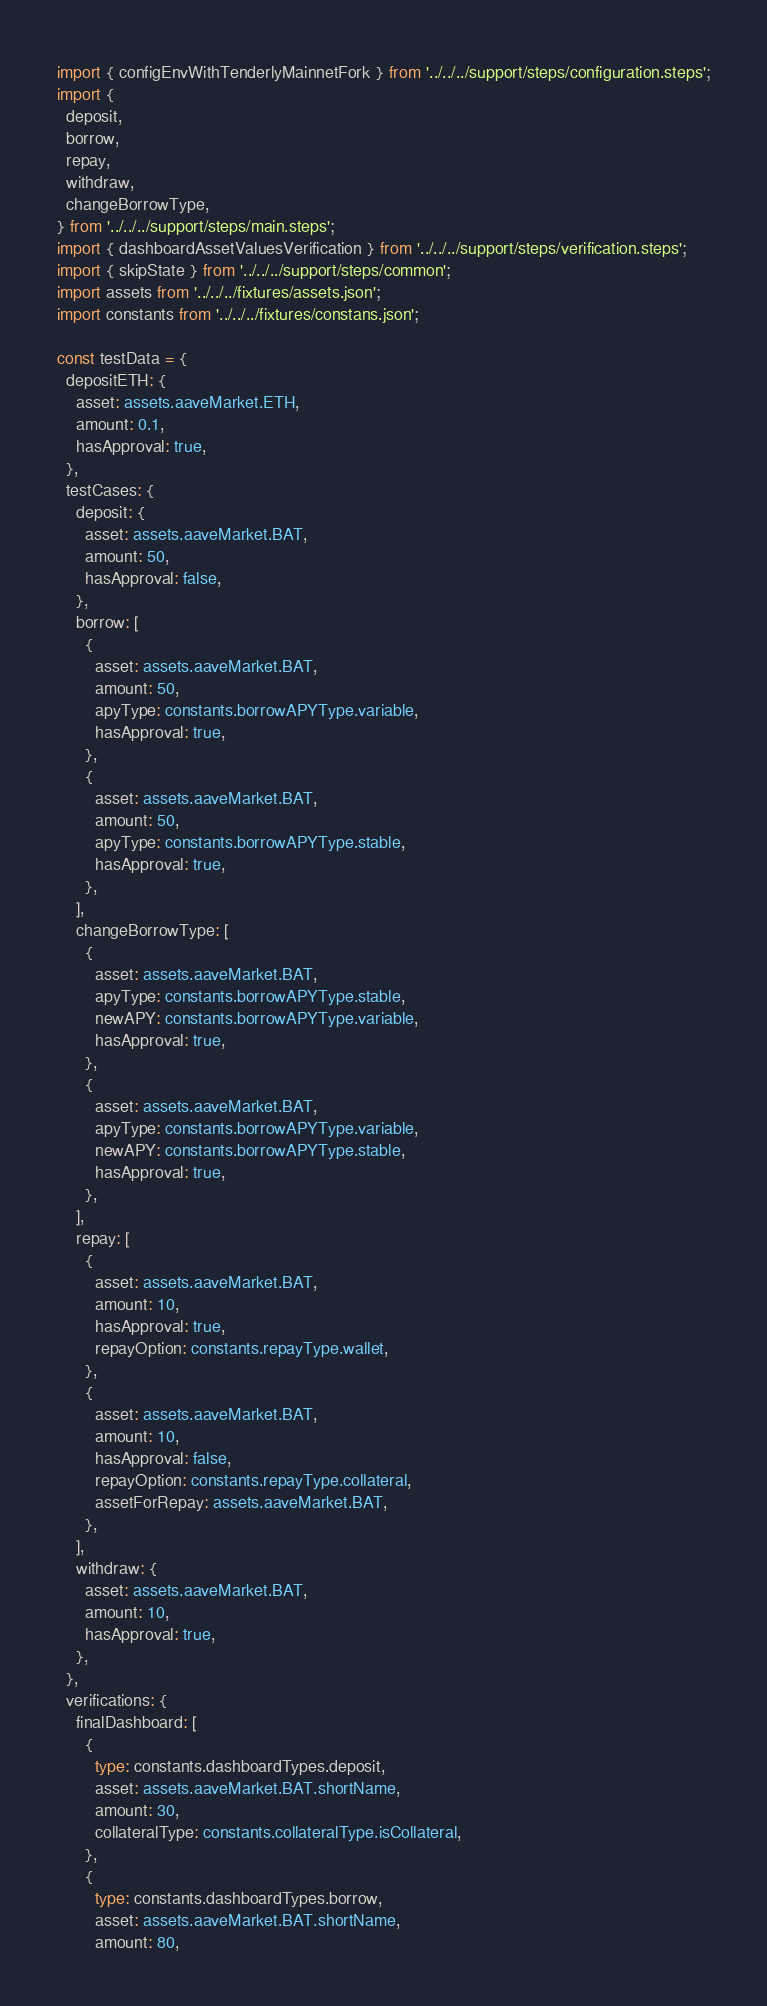Convert code to text. <code><loc_0><loc_0><loc_500><loc_500><_TypeScript_>import { configEnvWithTenderlyMainnetFork } from '../../../support/steps/configuration.steps';
import {
  deposit,
  borrow,
  repay,
  withdraw,
  changeBorrowType,
} from '../../../support/steps/main.steps';
import { dashboardAssetValuesVerification } from '../../../support/steps/verification.steps';
import { skipState } from '../../../support/steps/common';
import assets from '../../../fixtures/assets.json';
import constants from '../../../fixtures/constans.json';

const testData = {
  depositETH: {
    asset: assets.aaveMarket.ETH,
    amount: 0.1,
    hasApproval: true,
  },
  testCases: {
    deposit: {
      asset: assets.aaveMarket.BAT,
      amount: 50,
      hasApproval: false,
    },
    borrow: [
      {
        asset: assets.aaveMarket.BAT,
        amount: 50,
        apyType: constants.borrowAPYType.variable,
        hasApproval: true,
      },
      {
        asset: assets.aaveMarket.BAT,
        amount: 50,
        apyType: constants.borrowAPYType.stable,
        hasApproval: true,
      },
    ],
    changeBorrowType: [
      {
        asset: assets.aaveMarket.BAT,
        apyType: constants.borrowAPYType.stable,
        newAPY: constants.borrowAPYType.variable,
        hasApproval: true,
      },
      {
        asset: assets.aaveMarket.BAT,
        apyType: constants.borrowAPYType.variable,
        newAPY: constants.borrowAPYType.stable,
        hasApproval: true,
      },
    ],
    repay: [
      {
        asset: assets.aaveMarket.BAT,
        amount: 10,
        hasApproval: true,
        repayOption: constants.repayType.wallet,
      },
      {
        asset: assets.aaveMarket.BAT,
        amount: 10,
        hasApproval: false,
        repayOption: constants.repayType.collateral,
        assetForRepay: assets.aaveMarket.BAT,
      },
    ],
    withdraw: {
      asset: assets.aaveMarket.BAT,
      amount: 10,
      hasApproval: true,
    },
  },
  verifications: {
    finalDashboard: [
      {
        type: constants.dashboardTypes.deposit,
        asset: assets.aaveMarket.BAT.shortName,
        amount: 30,
        collateralType: constants.collateralType.isCollateral,
      },
      {
        type: constants.dashboardTypes.borrow,
        asset: assets.aaveMarket.BAT.shortName,
        amount: 80,</code> 